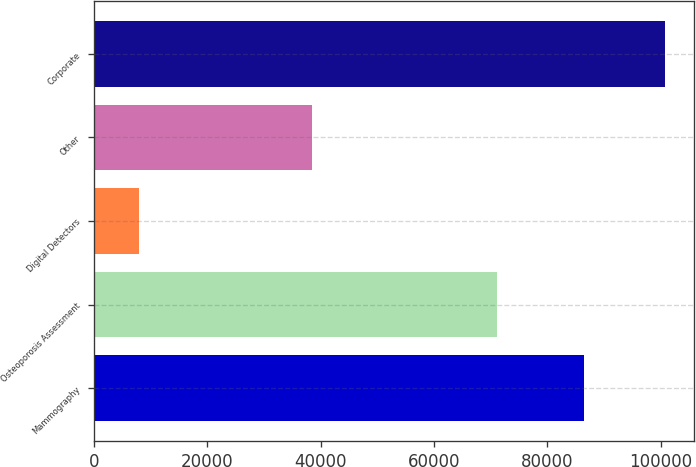Convert chart to OTSL. <chart><loc_0><loc_0><loc_500><loc_500><bar_chart><fcel>Mammography<fcel>Osteoporosis Assessment<fcel>Digital Detectors<fcel>Other<fcel>Corporate<nl><fcel>86473<fcel>71081<fcel>7990<fcel>38491<fcel>100810<nl></chart> 